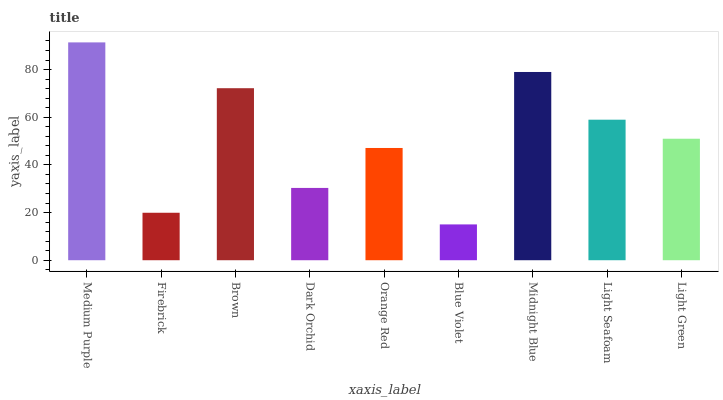Is Blue Violet the minimum?
Answer yes or no. Yes. Is Medium Purple the maximum?
Answer yes or no. Yes. Is Firebrick the minimum?
Answer yes or no. No. Is Firebrick the maximum?
Answer yes or no. No. Is Medium Purple greater than Firebrick?
Answer yes or no. Yes. Is Firebrick less than Medium Purple?
Answer yes or no. Yes. Is Firebrick greater than Medium Purple?
Answer yes or no. No. Is Medium Purple less than Firebrick?
Answer yes or no. No. Is Light Green the high median?
Answer yes or no. Yes. Is Light Green the low median?
Answer yes or no. Yes. Is Orange Red the high median?
Answer yes or no. No. Is Brown the low median?
Answer yes or no. No. 